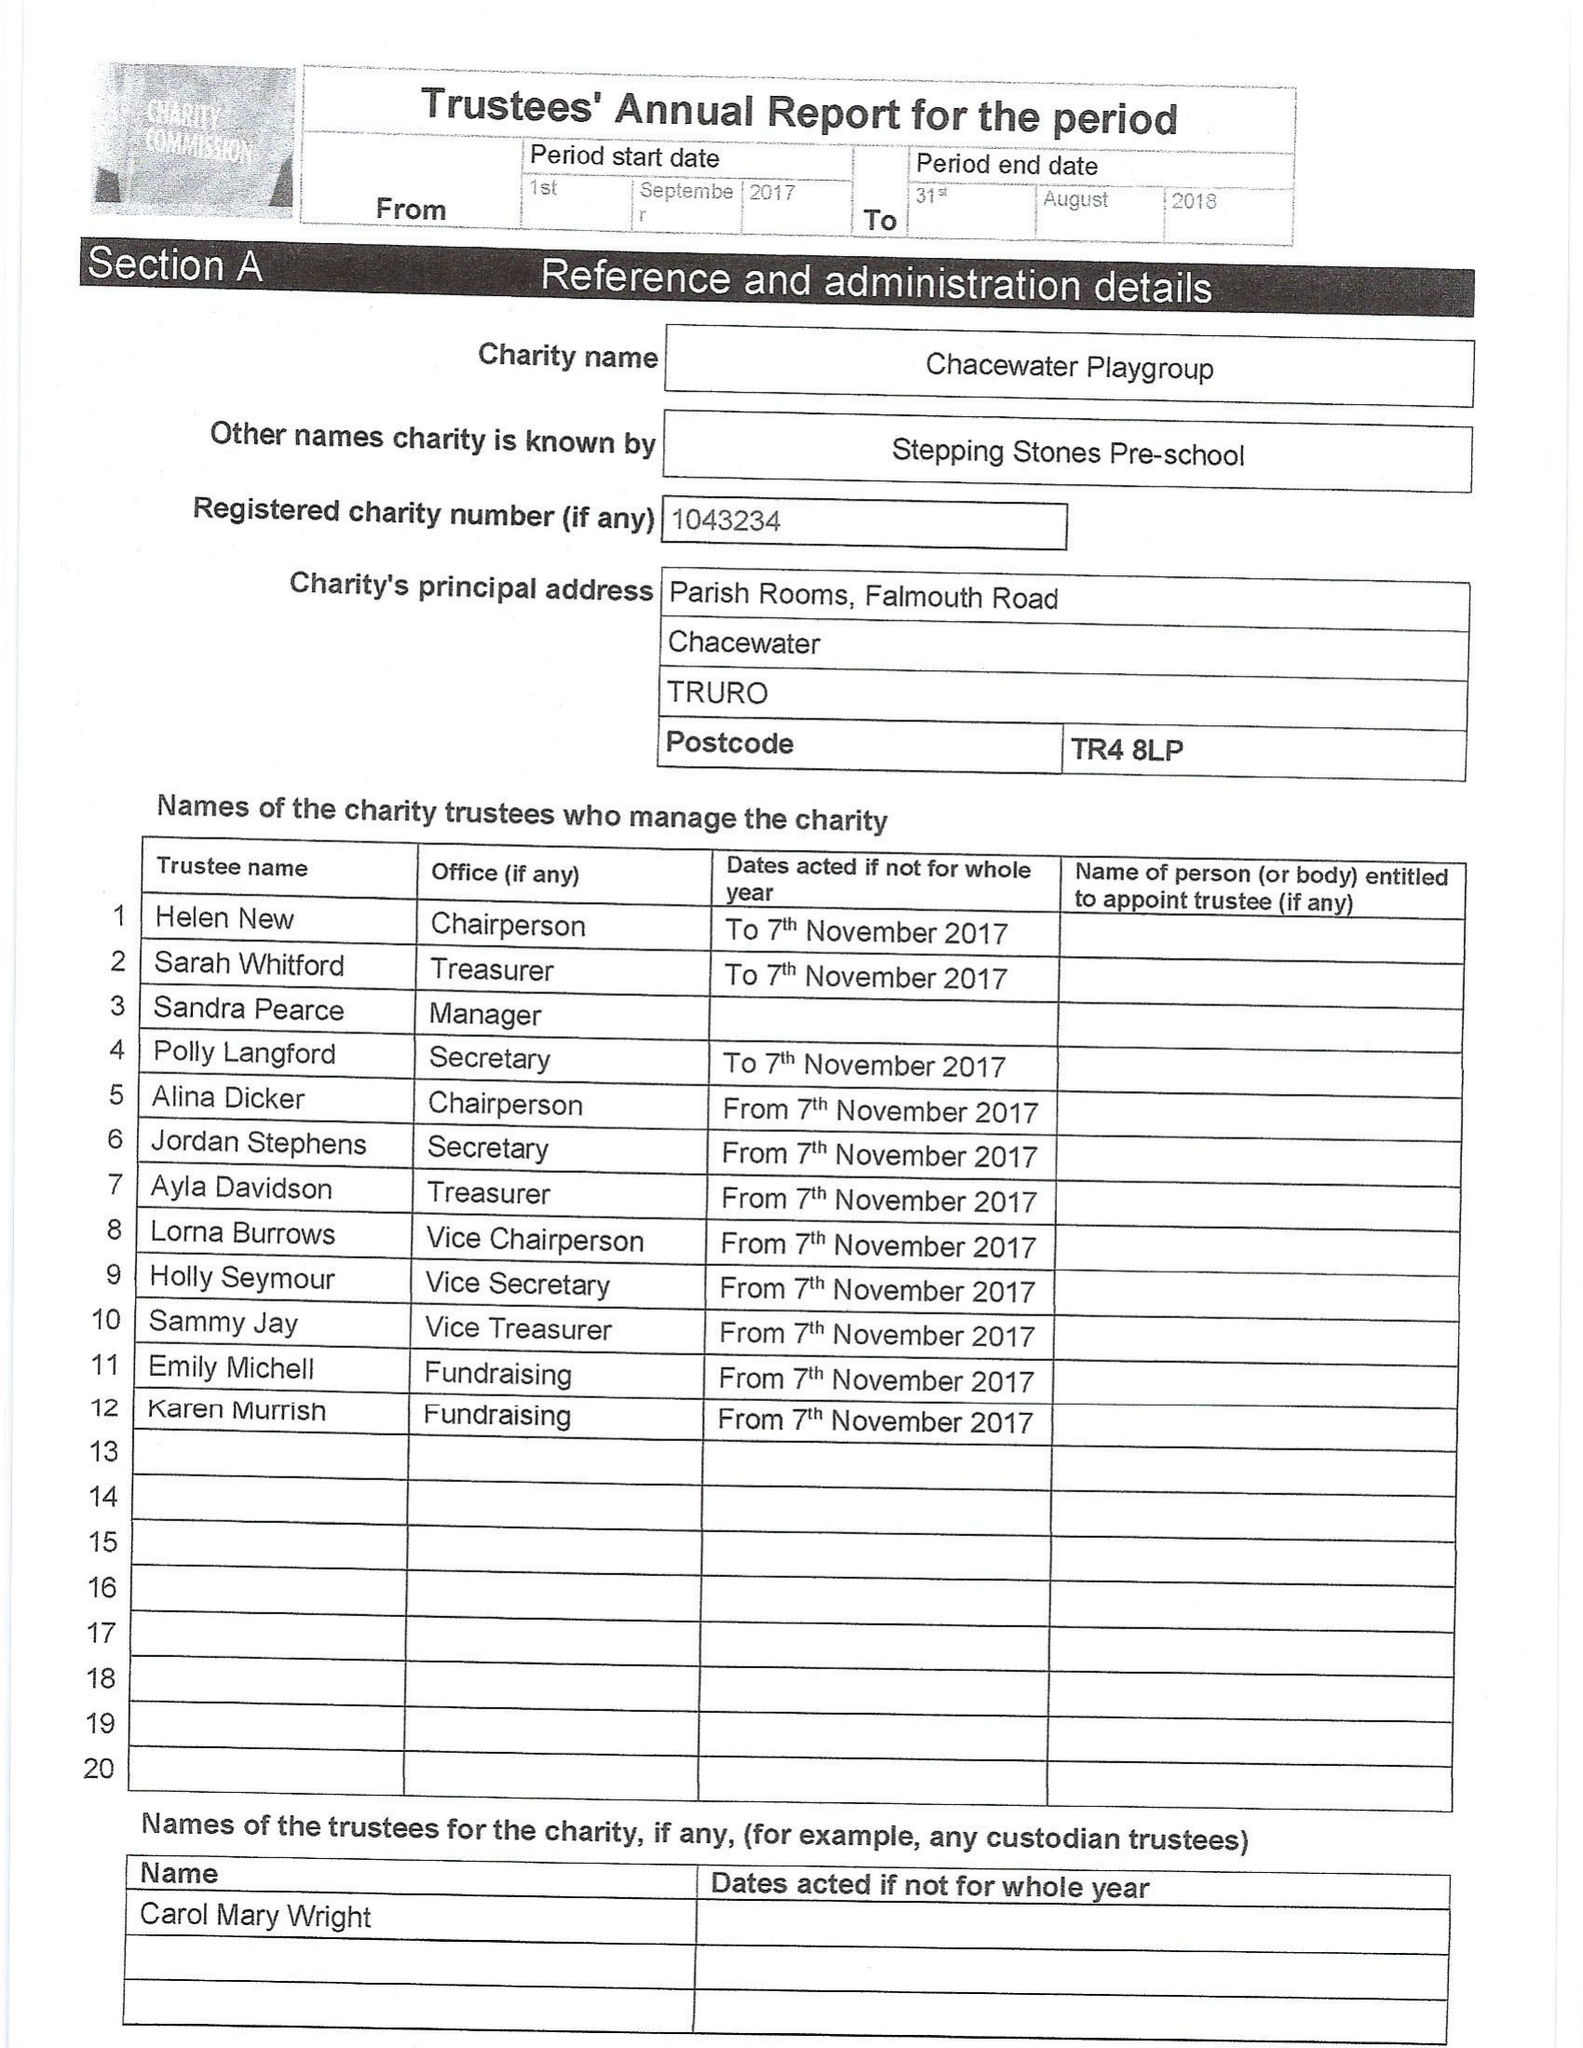What is the value for the report_date?
Answer the question using a single word or phrase. 2018-08-31 